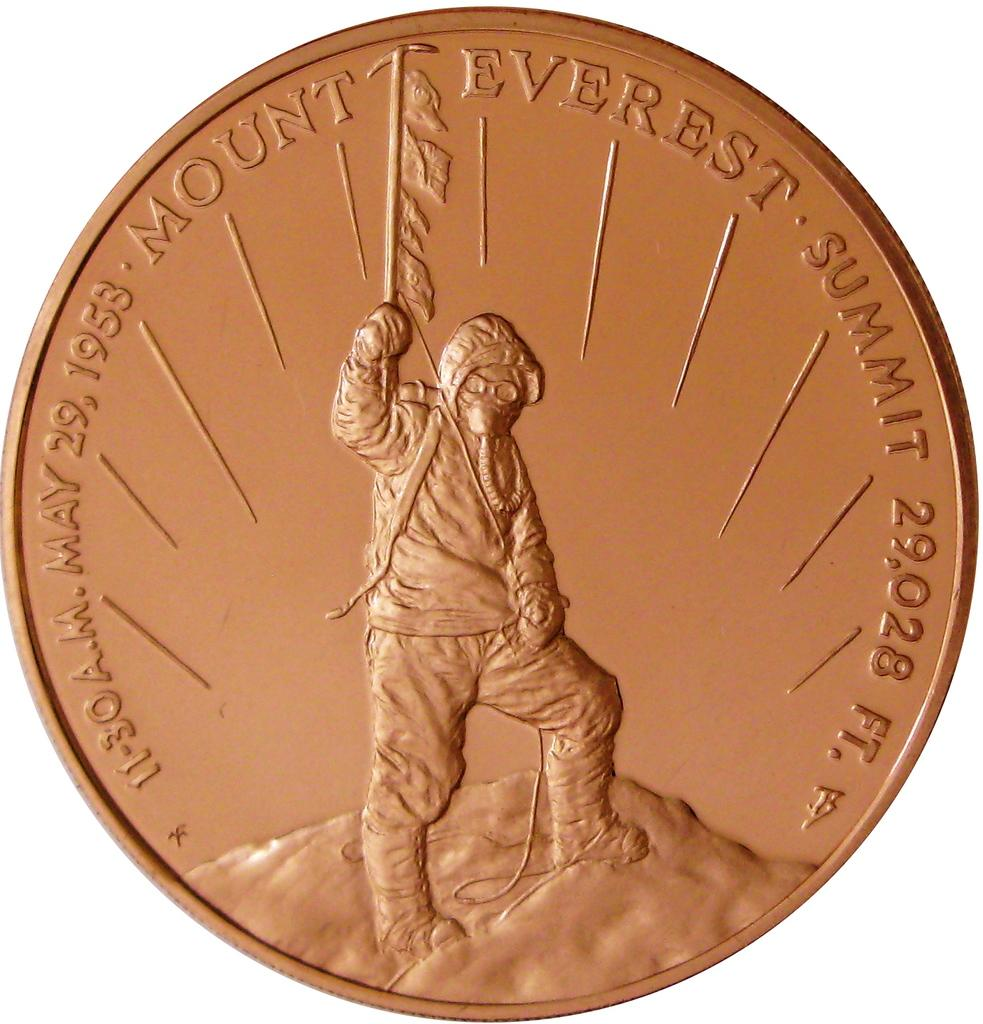<image>
Share a concise interpretation of the image provided. A gold May 29, 1958 Mount Everest Summit coin with an image of a man on the mountain. 